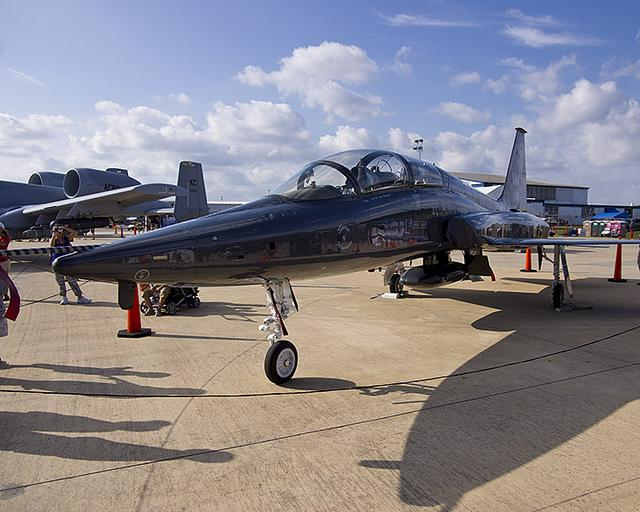Why is the plane parked here? no pilot 